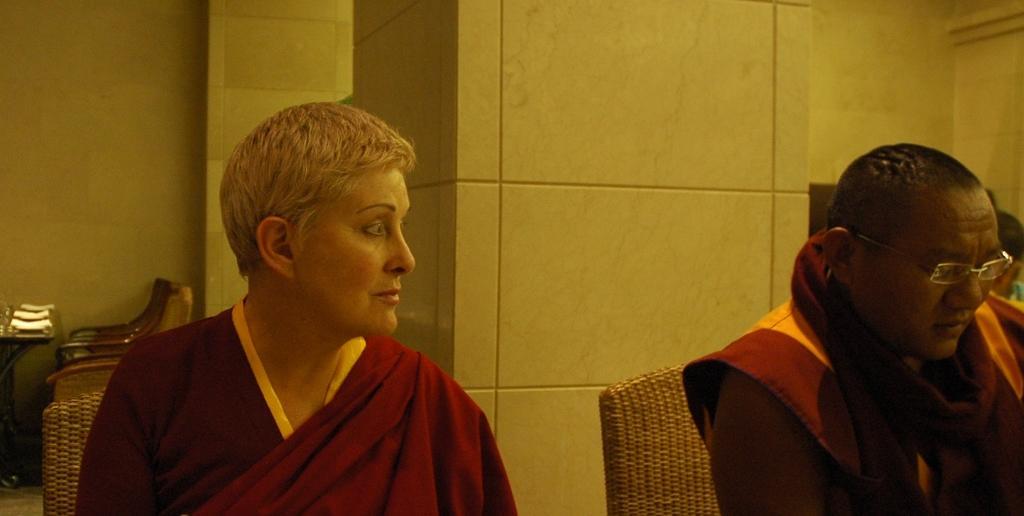Can you describe this image briefly? In the background we can see wall. We can see table and chair, on the table we can see objects. We can see two people sitting on the chairs. On the right side of the picture we can see a person wearing spectacles. We can also see another person. 